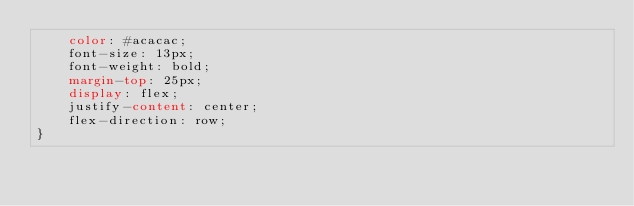Convert code to text. <code><loc_0><loc_0><loc_500><loc_500><_CSS_>    color: #acacac;
    font-size: 13px;
    font-weight: bold;
    margin-top: 25px;
    display: flex;
    justify-content: center;
    flex-direction: row;
}</code> 